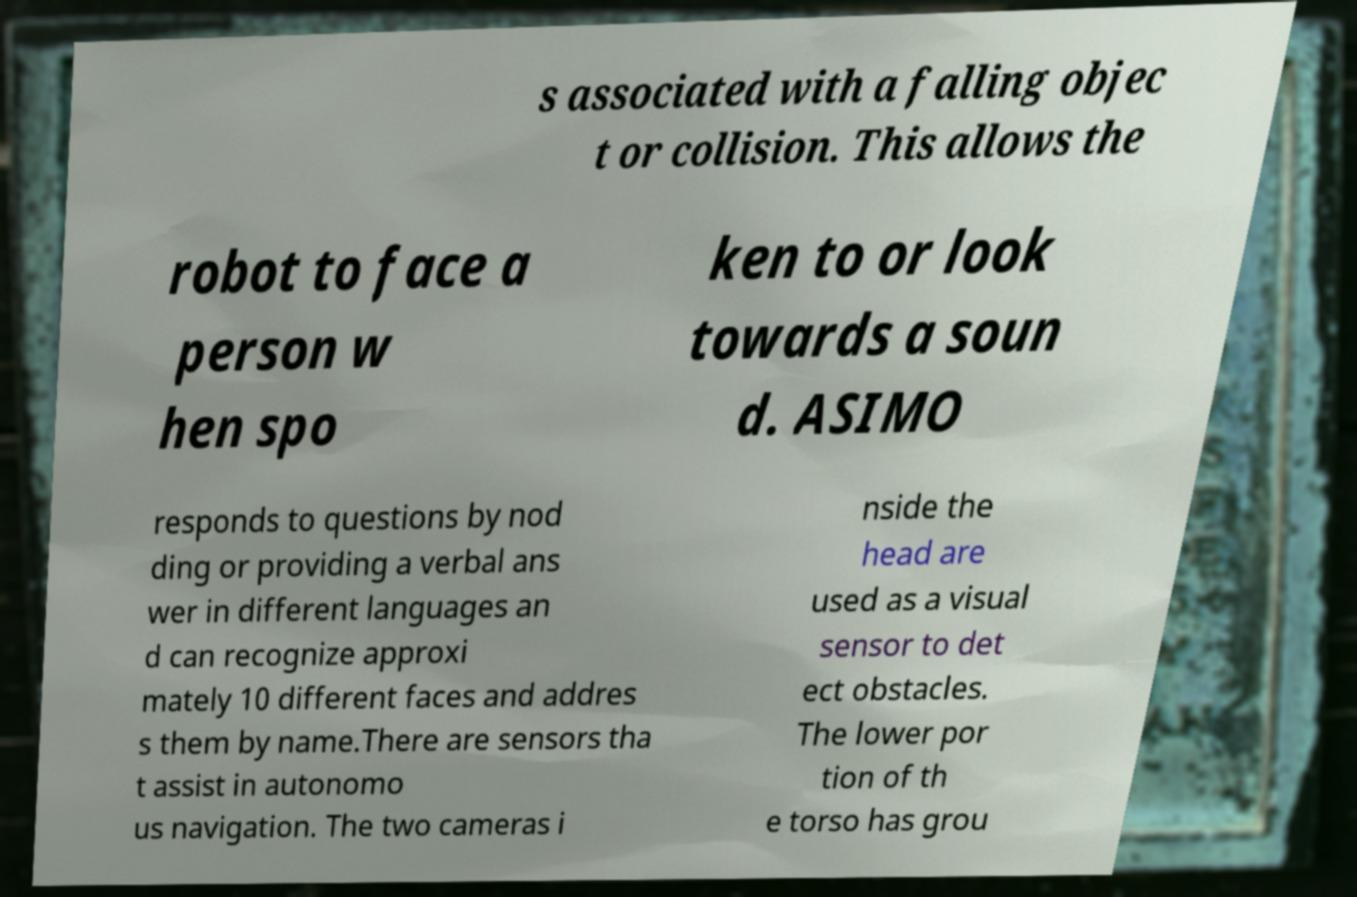Can you read and provide the text displayed in the image?This photo seems to have some interesting text. Can you extract and type it out for me? s associated with a falling objec t or collision. This allows the robot to face a person w hen spo ken to or look towards a soun d. ASIMO responds to questions by nod ding or providing a verbal ans wer in different languages an d can recognize approxi mately 10 different faces and addres s them by name.There are sensors tha t assist in autonomo us navigation. The two cameras i nside the head are used as a visual sensor to det ect obstacles. The lower por tion of th e torso has grou 